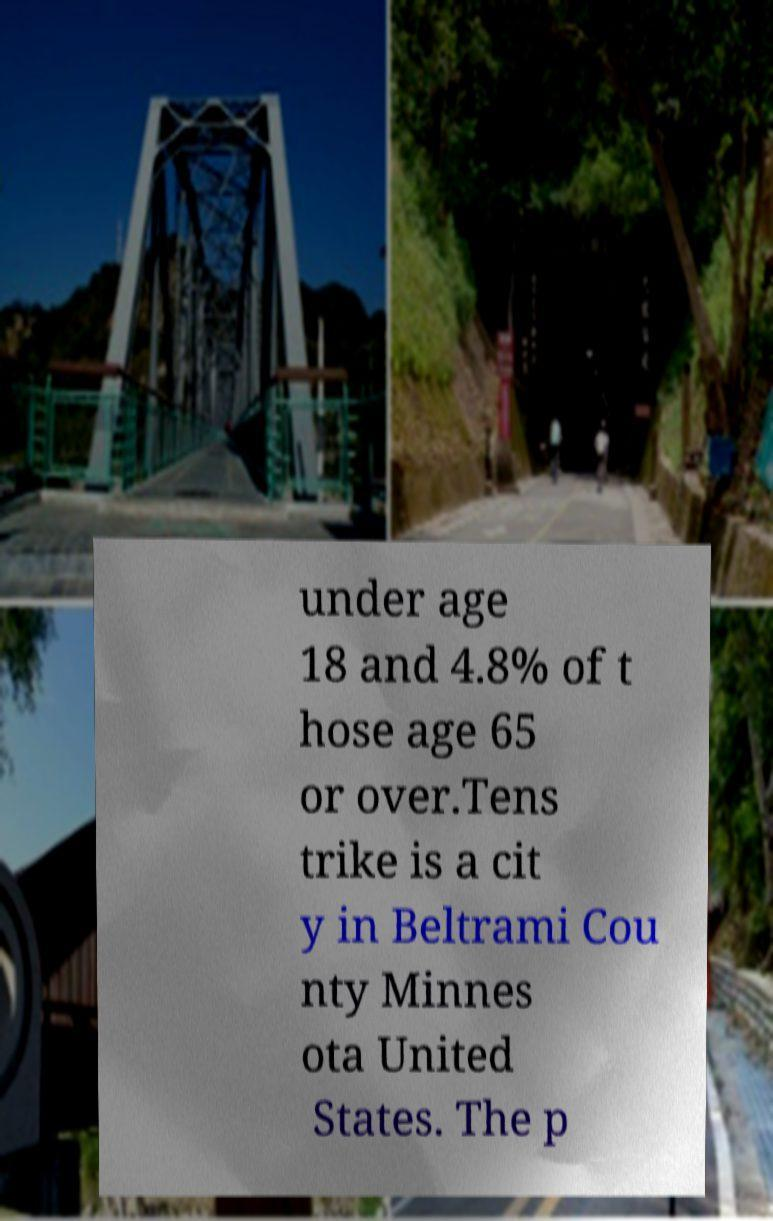Could you assist in decoding the text presented in this image and type it out clearly? under age 18 and 4.8% of t hose age 65 or over.Tens trike is a cit y in Beltrami Cou nty Minnes ota United States. The p 